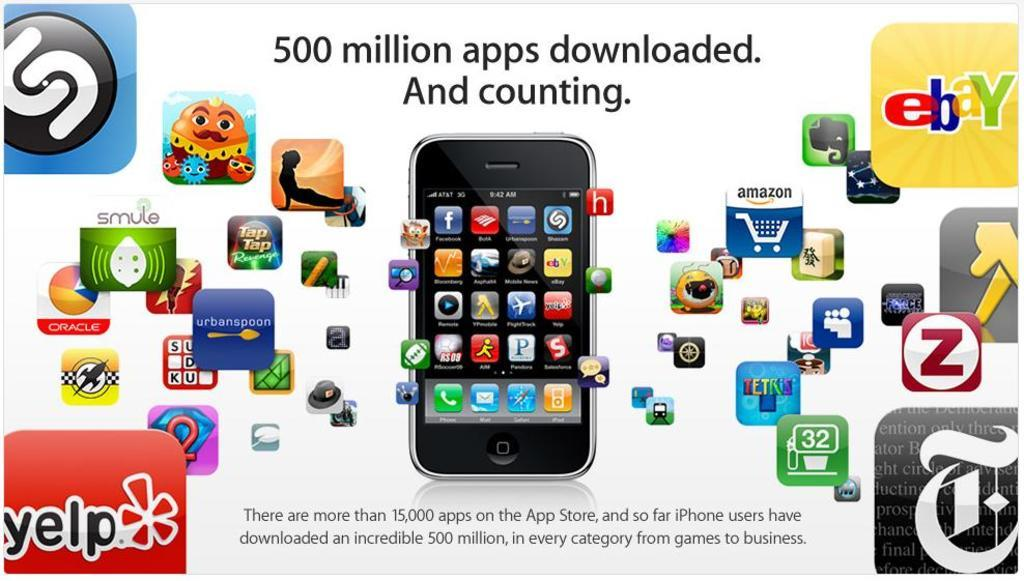<image>
Present a compact description of the photo's key features. A graphic showing that over 500 million iPhone apps have been downloaded 